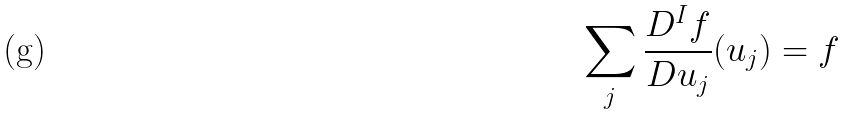Convert formula to latex. <formula><loc_0><loc_0><loc_500><loc_500>\sum _ { j } \frac { D ^ { I } f } { D u _ { j } } ( u _ { j } ) = f</formula> 